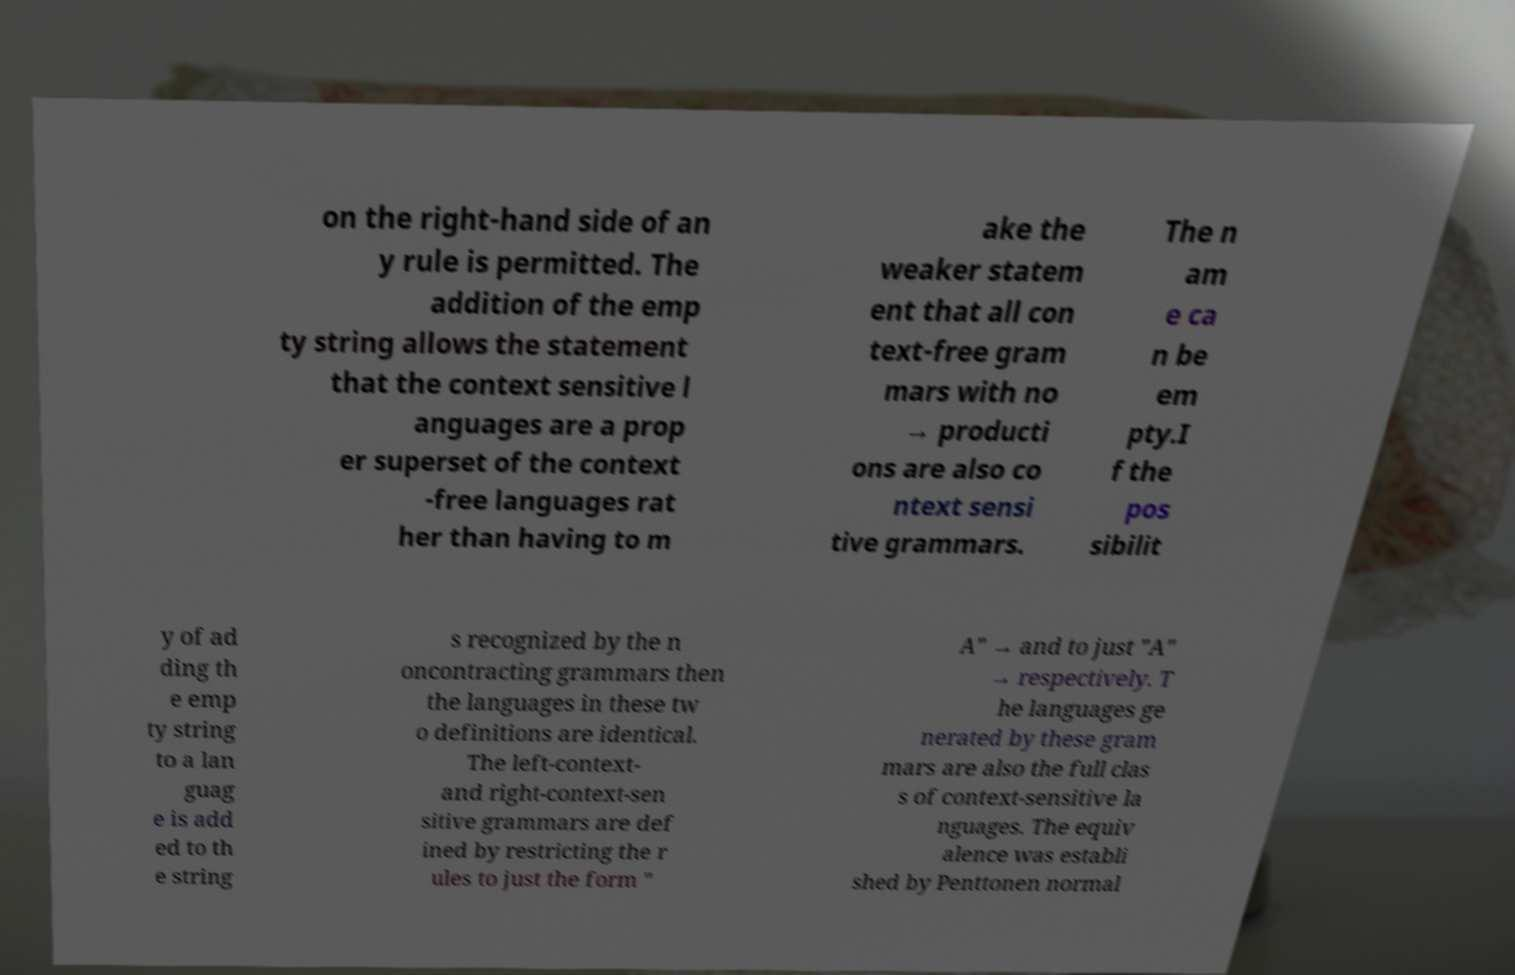There's text embedded in this image that I need extracted. Can you transcribe it verbatim? on the right-hand side of an y rule is permitted. The addition of the emp ty string allows the statement that the context sensitive l anguages are a prop er superset of the context -free languages rat her than having to m ake the weaker statem ent that all con text-free gram mars with no → producti ons are also co ntext sensi tive grammars. The n am e ca n be em pty.I f the pos sibilit y of ad ding th e emp ty string to a lan guag e is add ed to th e string s recognized by the n oncontracting grammars then the languages in these tw o definitions are identical. The left-context- and right-context-sen sitive grammars are def ined by restricting the r ules to just the form " A" → and to just "A" → respectively. T he languages ge nerated by these gram mars are also the full clas s of context-sensitive la nguages. The equiv alence was establi shed by Penttonen normal 